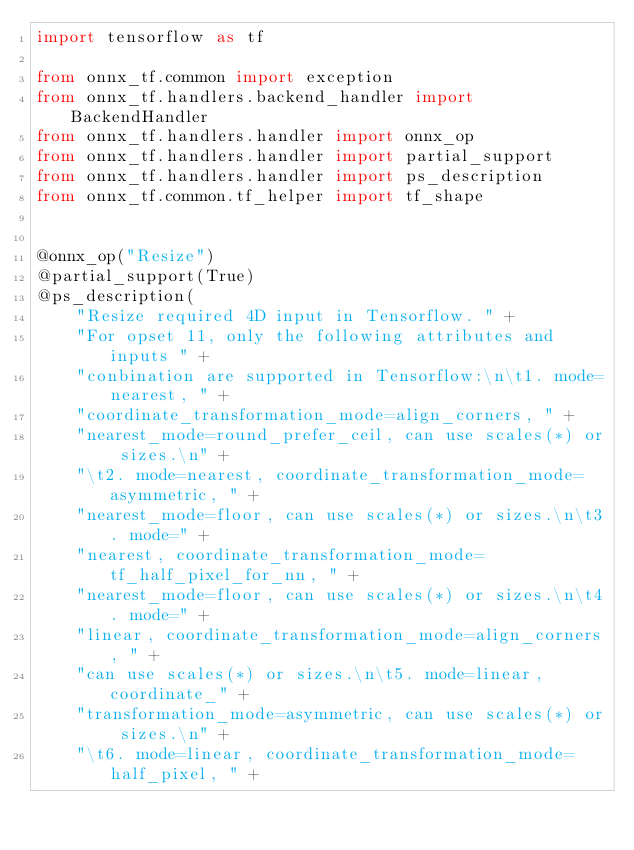<code> <loc_0><loc_0><loc_500><loc_500><_Python_>import tensorflow as tf

from onnx_tf.common import exception
from onnx_tf.handlers.backend_handler import BackendHandler
from onnx_tf.handlers.handler import onnx_op
from onnx_tf.handlers.handler import partial_support
from onnx_tf.handlers.handler import ps_description
from onnx_tf.common.tf_helper import tf_shape


@onnx_op("Resize")
@partial_support(True)
@ps_description(
    "Resize required 4D input in Tensorflow. " +
    "For opset 11, only the following attributes and inputs " +
    "conbination are supported in Tensorflow:\n\t1. mode=nearest, " +
    "coordinate_transformation_mode=align_corners, " +
    "nearest_mode=round_prefer_ceil, can use scales(*) or sizes.\n" +
    "\t2. mode=nearest, coordinate_transformation_mode=asymmetric, " +
    "nearest_mode=floor, can use scales(*) or sizes.\n\t3. mode=" +
    "nearest, coordinate_transformation_mode=tf_half_pixel_for_nn, " +
    "nearest_mode=floor, can use scales(*) or sizes.\n\t4. mode=" +
    "linear, coordinate_transformation_mode=align_corners, " +
    "can use scales(*) or sizes.\n\t5. mode=linear, coordinate_" +
    "transformation_mode=asymmetric, can use scales(*) or sizes.\n" +
    "\t6. mode=linear, coordinate_transformation_mode=half_pixel, " +</code> 